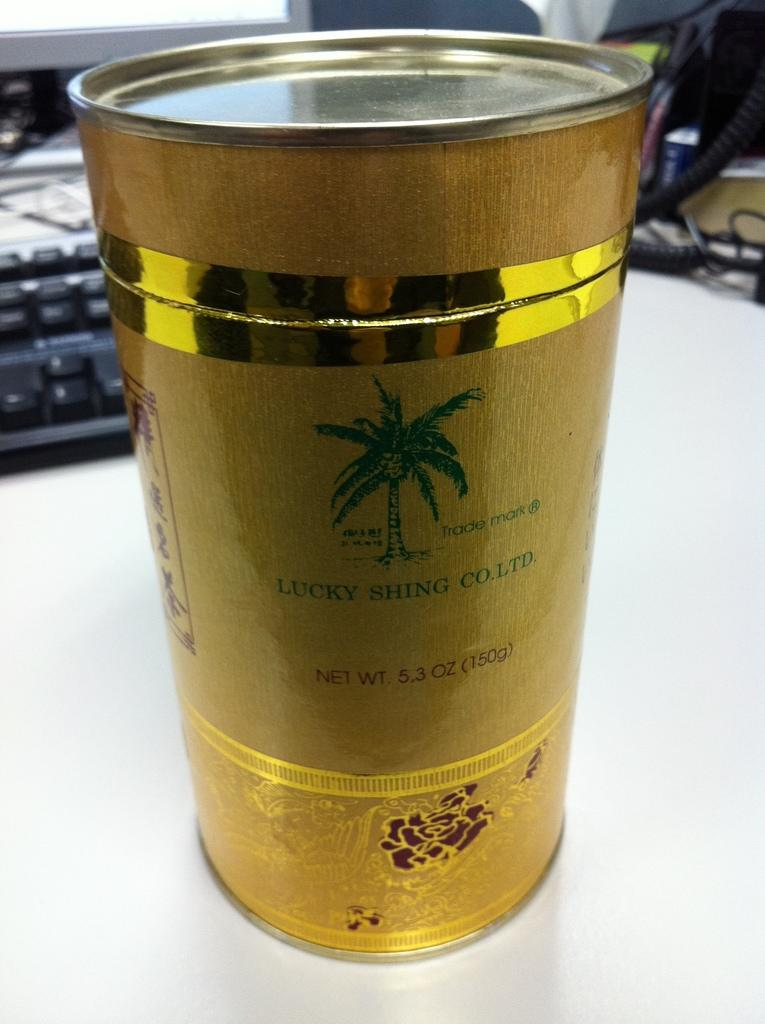Provide a one-sentence caption for the provided image. A gold canister from Lucky Shing Co. Ltd. weighs 5.3 oz. 